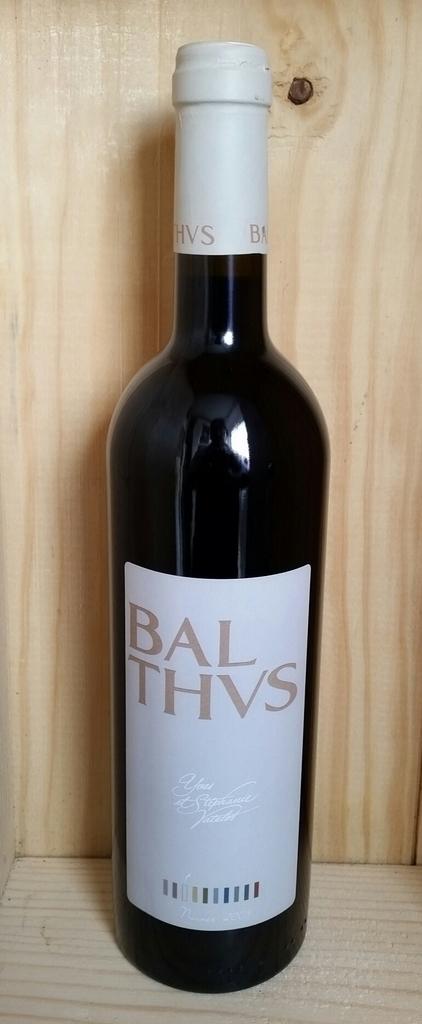What is the brand of this wine?
Offer a very short reply. Balthvs. 